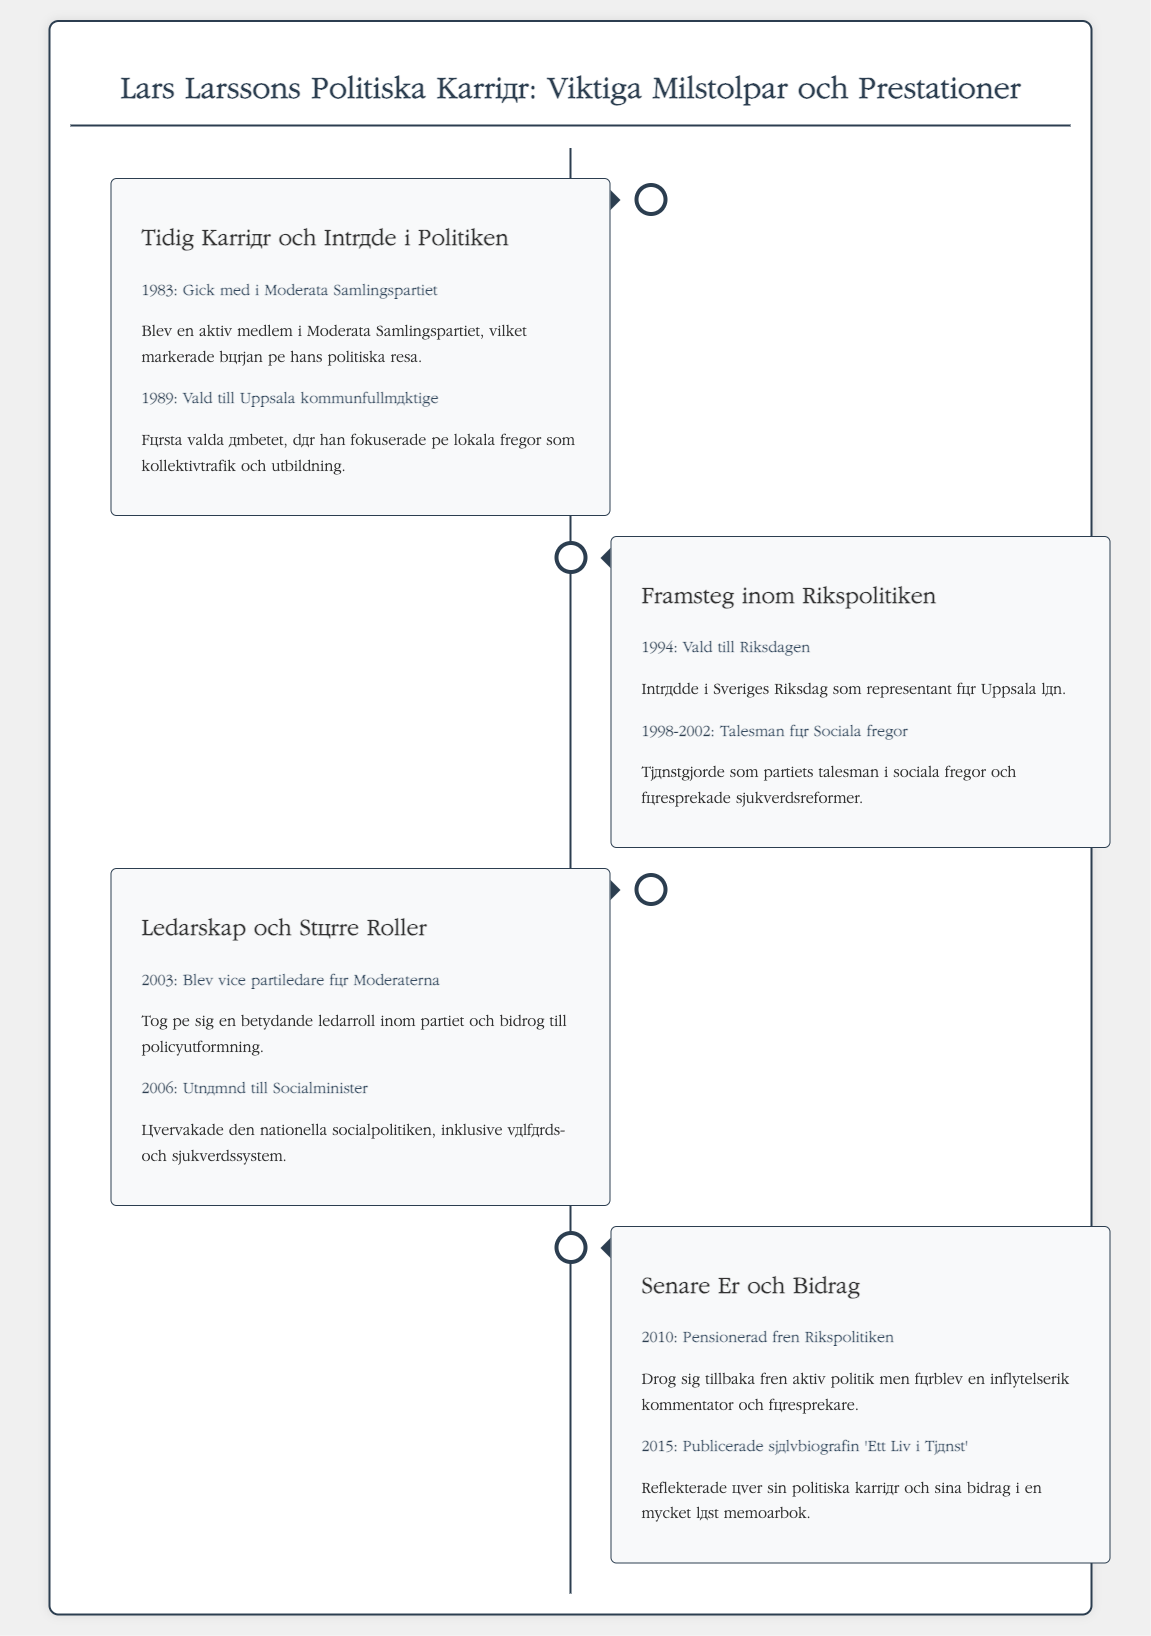What year did Larsson join the Moderata Samlingspartiet? The document states that Larsson joined the Moderata Samlingspartiet in 1983.
Answer: 1983 What was Larsson's first elected position? The document mentions that his first elected position was a member of Uppsala kommunfullmäktige in 1989.
Answer: Uppsala kommunfullmäktige What role did Larsson have from 1998 to 2002? According to the document, Larsson served as the party's spokesman on social issues during that time.
Answer: Talesman för Sociala frågor When was Larsson appointed as Socialminister? The document states that Larsson was appointed as Socialminister in 2006.
Answer: 2006 What significant publication did Larsson release in 2015? The document mentions that he published his autobiography titled 'Ett Liv i Tjänst' in 2015.
Answer: 'Ett Liv i Tjänst' What major political role did Larsson take on in 2003? The document indicates that he became vice party leader for Moderaterna in 2003.
Answer: Vice partiledare för Moderaterna How long did Larsson serve in Rikspolitiken? Based on the document, Larsson was active in Rikspolitiken until his retirement in 2010, serving continuously from 1994.
Answer: 16 years What are the themes covered in Larsson's autobiography? The document indicates that he reflected on his political career and contributions in his autobiography.
Answer: Politisk karriär och bidrag 